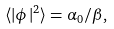<formula> <loc_0><loc_0><loc_500><loc_500>\langle | \phi | ^ { 2 } \rangle = \alpha _ { 0 } / \beta ,</formula> 